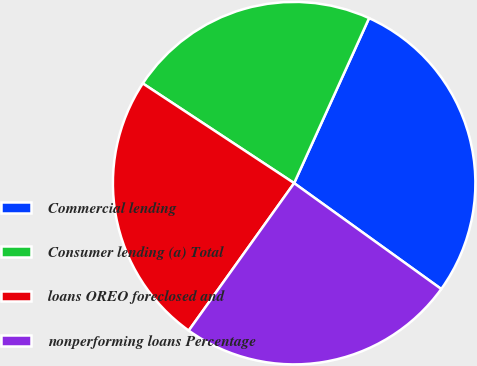<chart> <loc_0><loc_0><loc_500><loc_500><pie_chart><fcel>Commercial lending<fcel>Consumer lending (a) Total<fcel>loans OREO foreclosed and<fcel>nonperforming loans Percentage<nl><fcel>28.14%<fcel>22.51%<fcel>24.39%<fcel>24.95%<nl></chart> 